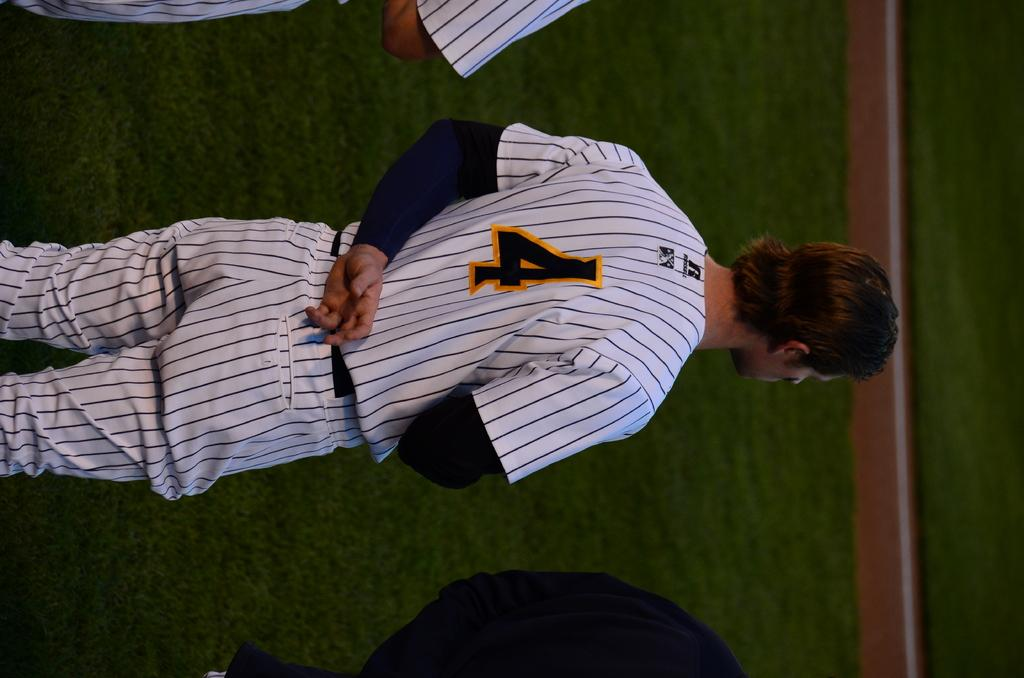<image>
Give a short and clear explanation of the subsequent image. Man wearing a number 4 on his jersey standing with his arm behind his back. 